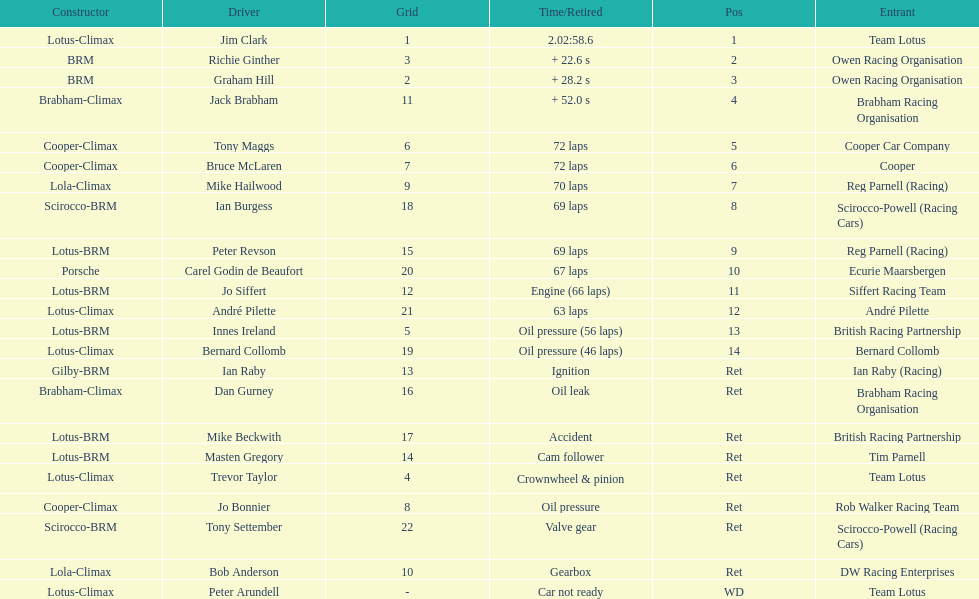What was the same problem that bernard collomb had as innes ireland? Oil pressure. 